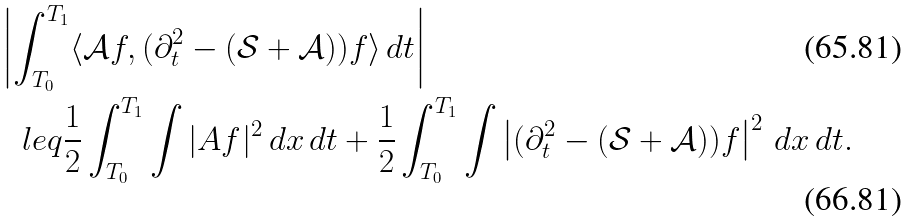Convert formula to latex. <formula><loc_0><loc_0><loc_500><loc_500>& \left | \int _ { T _ { 0 } } ^ { T _ { 1 } } \langle \mathcal { A } f , ( \partial _ { t } ^ { 2 } - ( \mathcal { S } + \mathcal { A } ) ) f \rangle \, d t \right | \\ & \ \ \ l e q \frac { 1 } { 2 } \int _ { T _ { 0 } } ^ { T _ { 1 } } \int | A f | ^ { 2 } \, d x \, d t + \frac { 1 } { 2 } \int _ { T _ { 0 } } ^ { T _ { 1 } } \int \left | ( \partial _ { t } ^ { 2 } - ( \mathcal { S } + \mathcal { A } ) ) f \right | ^ { 2 } \, d x \, d t .</formula> 